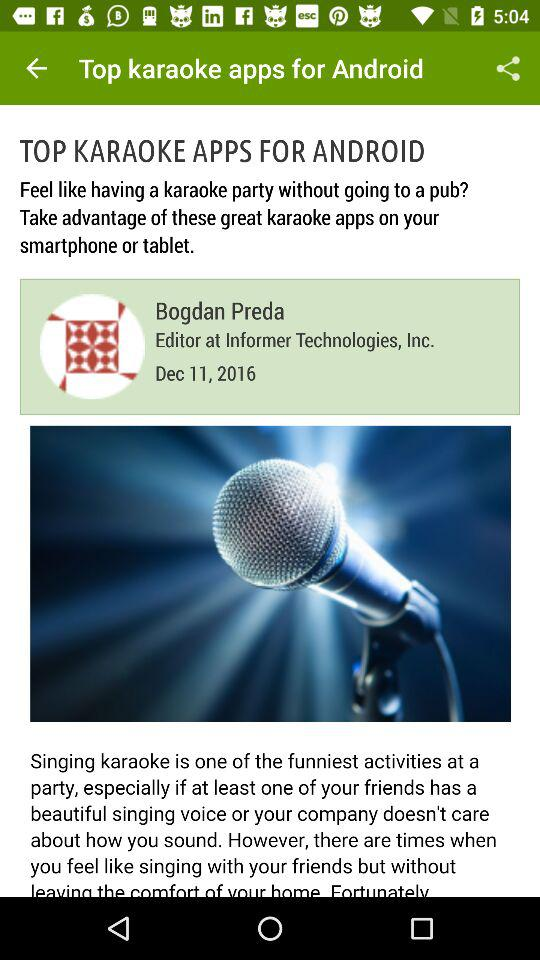What is the published date? The published date is December 11, 2016. 